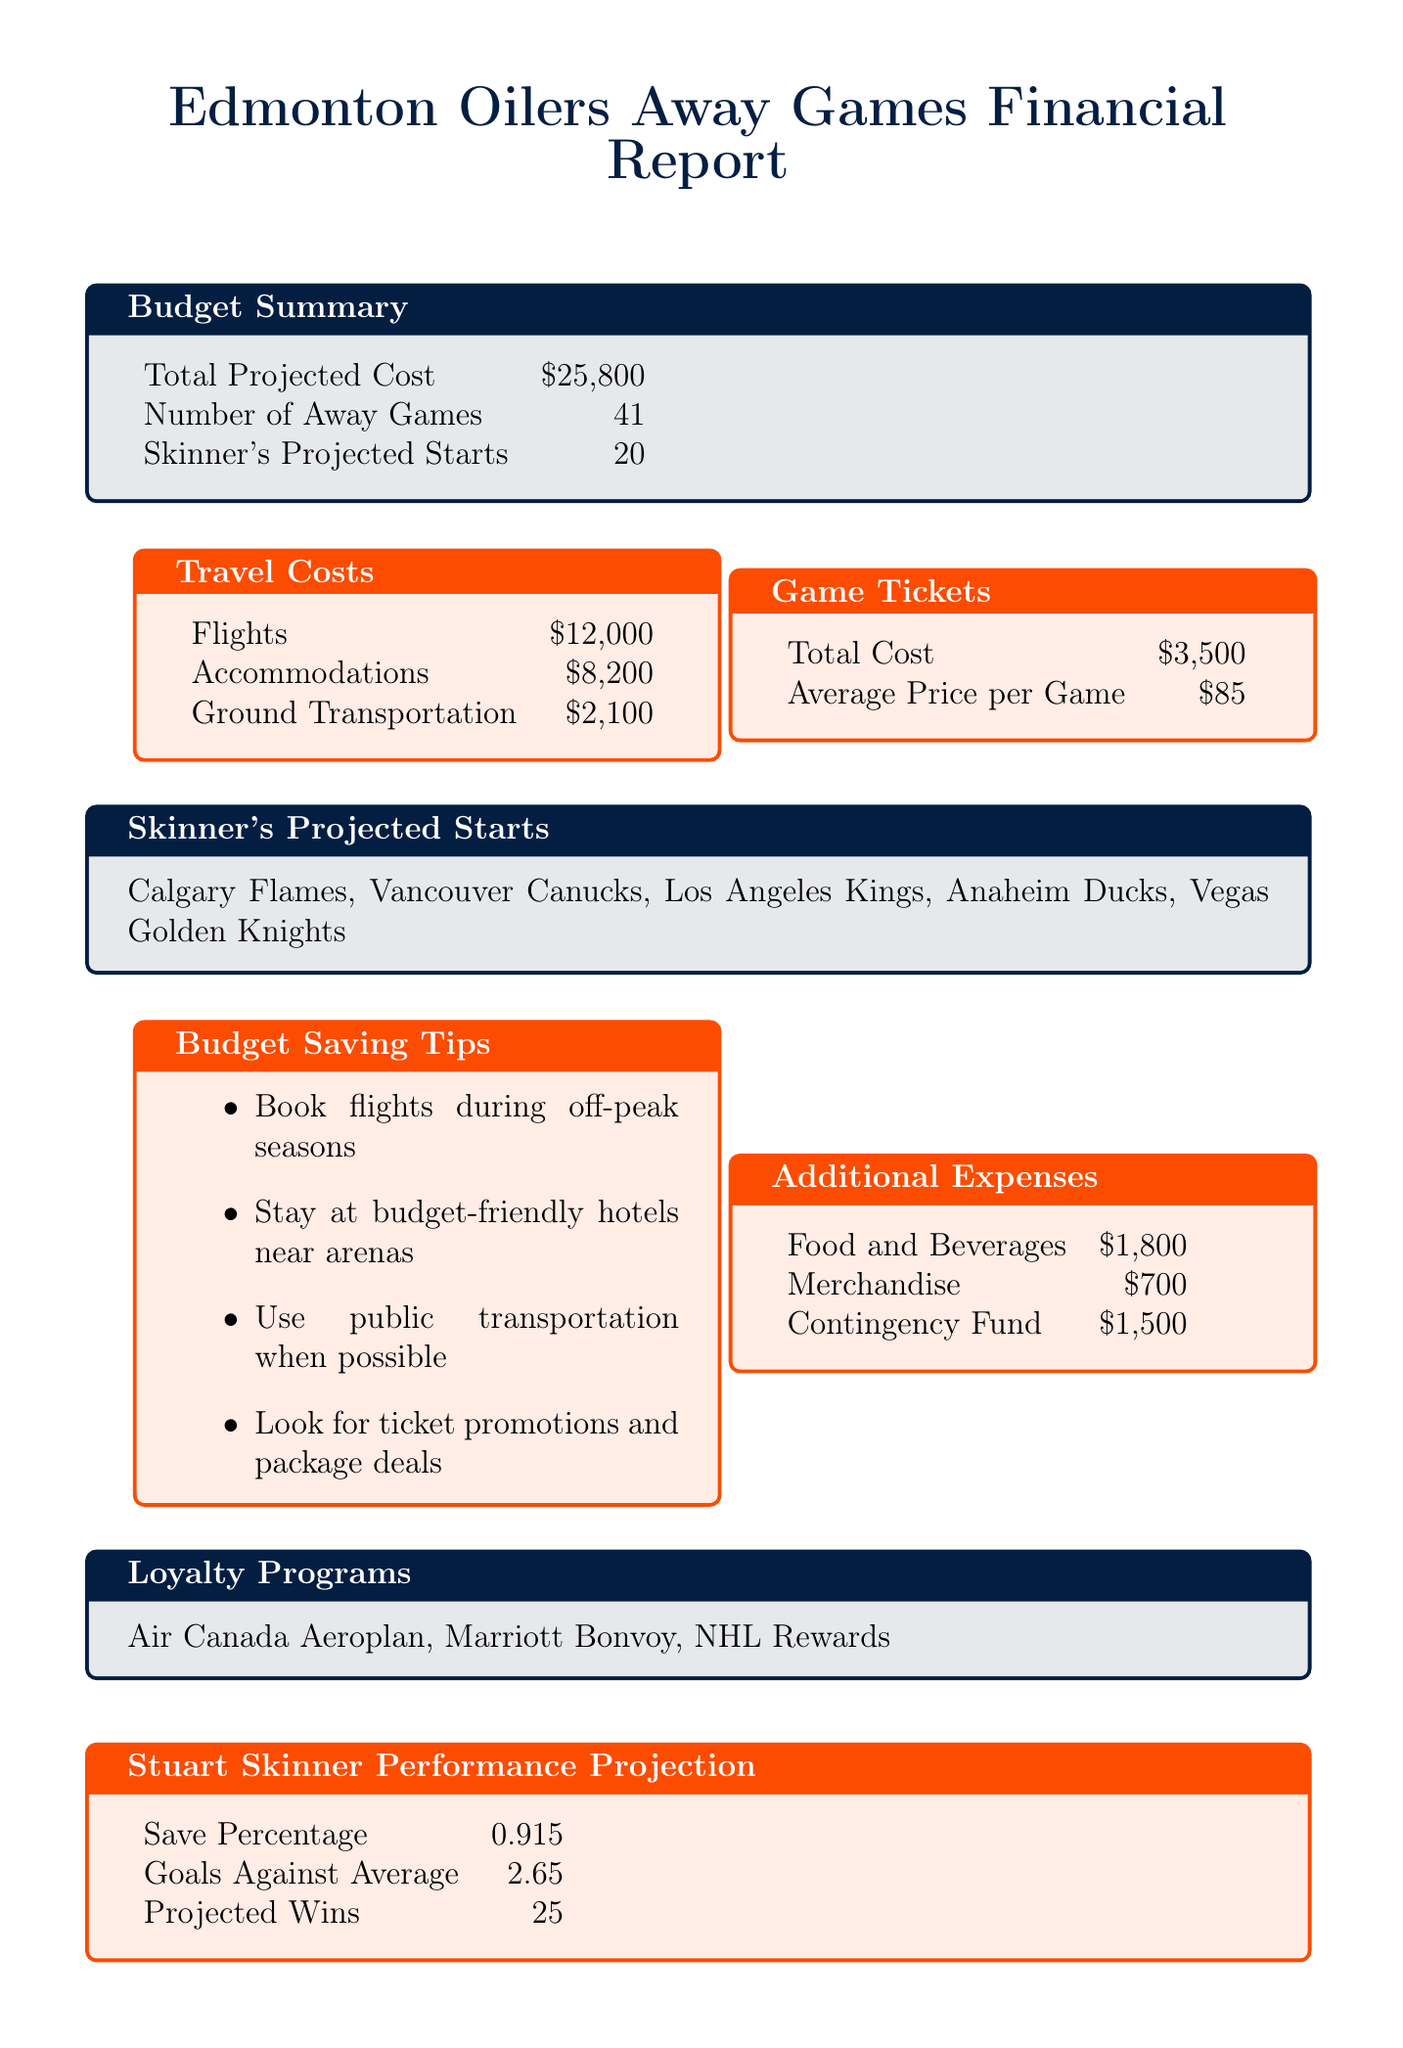what is the total projected cost? The total projected cost is listed in the budget summary of the document, which amounts to $25,800.
Answer: $25,800 how many away games are there? The number of away games is specified in the budget summary as 41.
Answer: 41 which teams is Stuart Skinner likely to start against? The document lists the teams where Stuart Skinner is projected to start, including Calgary Flames, Vancouver Canucks, Los Angeles Kings, Anaheim Ducks, and Vegas Golden Knights.
Answer: Calgary Flames, Vancouver Canucks, Los Angeles Kings, Anaheim Ducks, Vegas Golden Knights what is the cost of game tickets? The total cost for game tickets is provided in the game tickets section of the document, which is $3,500.
Answer: $3,500 what is the average price per game for tickets? The average price per game for tickets is stated as $85 in the document.
Answer: $85 how much is allocated for food and beverages? The additional expenses section indicates that $1,800 is budgeted for food and beverages.
Answer: $1,800 how many projected wins does Stuart Skinner have? The document states that Stuart Skinner's projected wins for the season are 25.
Answer: 25 what is one of the budget saving tips? The document lists multiple budget saving tips, one of which is to book flights during off-peak seasons.
Answer: Book flights during off-peak seasons what is the save percentage for Stuart Skinner? The save percentage for Stuart Skinner is given as 0.915 in his performance projection section.
Answer: 0.915 